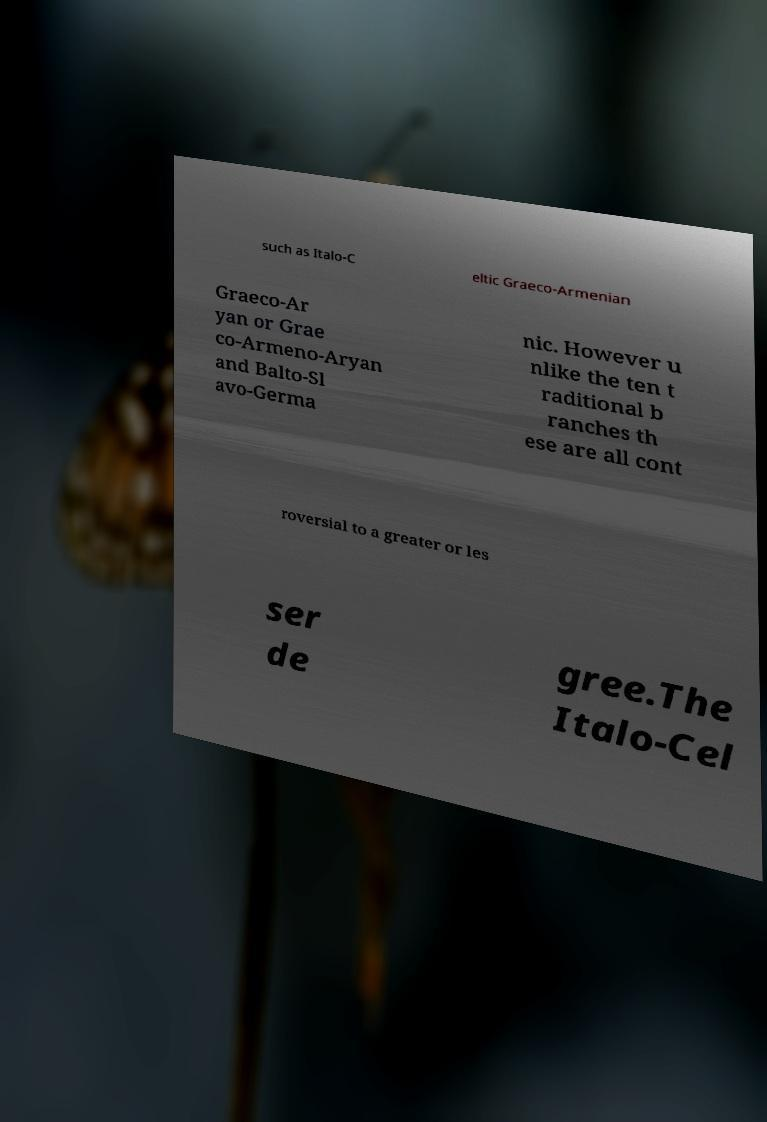There's text embedded in this image that I need extracted. Can you transcribe it verbatim? such as Italo-C eltic Graeco-Armenian Graeco-Ar yan or Grae co-Armeno-Aryan and Balto-Sl avo-Germa nic. However u nlike the ten t raditional b ranches th ese are all cont roversial to a greater or les ser de gree.The Italo-Cel 